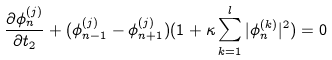Convert formula to latex. <formula><loc_0><loc_0><loc_500><loc_500>\frac { \partial \phi ^ { ( j ) } _ { n } } { \partial t _ { 2 } } + ( \phi _ { n - 1 } ^ { ( j ) } - \phi _ { n + 1 } ^ { ( j ) } ) ( 1 + \kappa \sum _ { k = 1 } ^ { l } | \phi _ { n } ^ { ( k ) } | ^ { 2 } ) = 0</formula> 